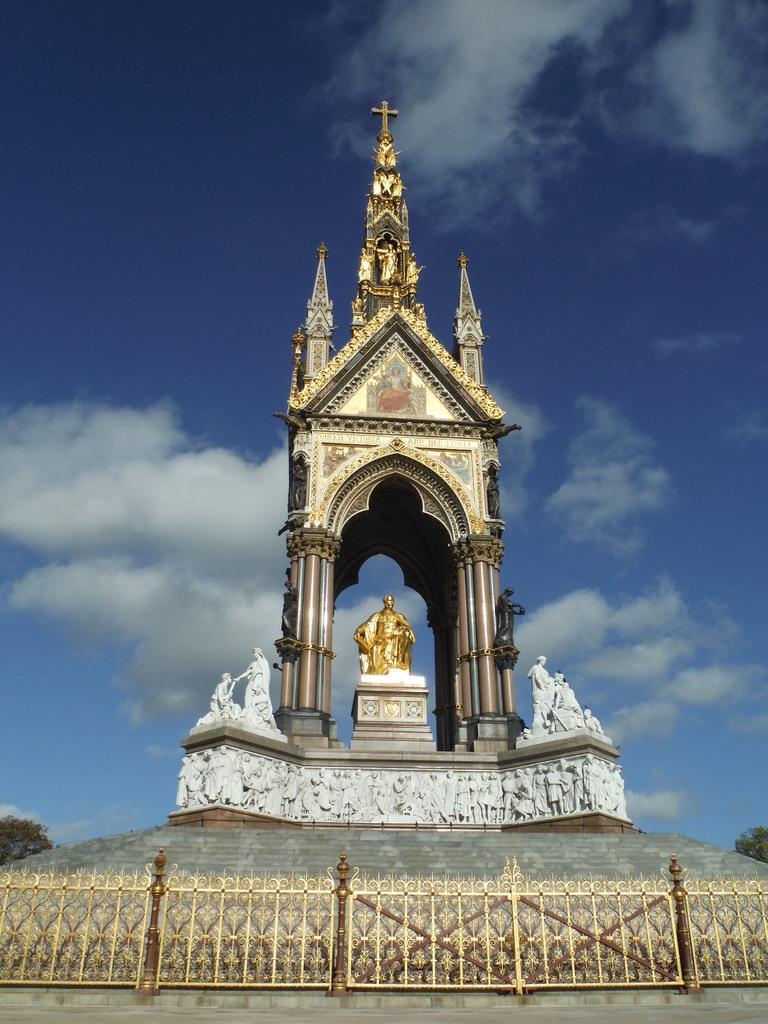In one or two sentences, can you explain what this image depicts? In this image there is an arch in the middle. In the arch there is a statue. At the top there is a cross symbol. At the bottom there is a fence. At the top there is the sky. There are sculptures around the arch. 